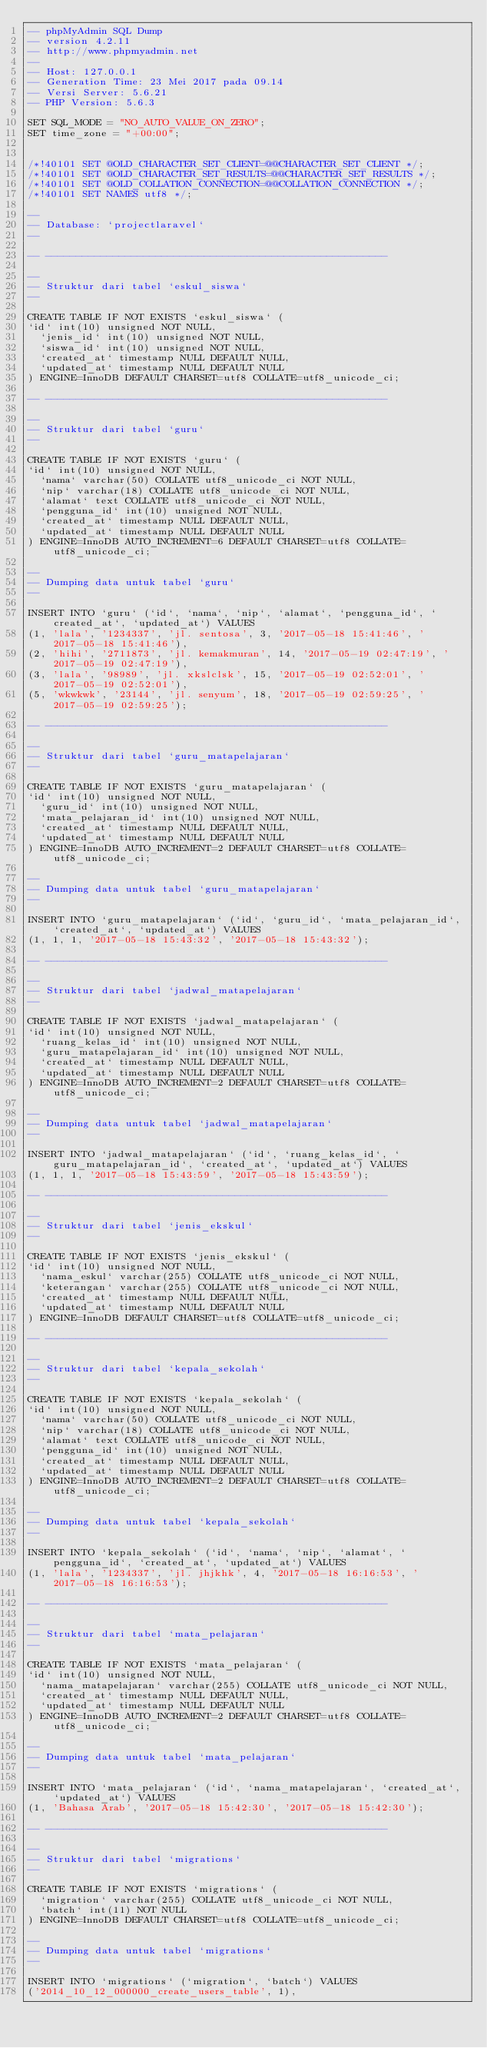Convert code to text. <code><loc_0><loc_0><loc_500><loc_500><_SQL_>-- phpMyAdmin SQL Dump
-- version 4.2.11
-- http://www.phpmyadmin.net
--
-- Host: 127.0.0.1
-- Generation Time: 23 Mei 2017 pada 09.14
-- Versi Server: 5.6.21
-- PHP Version: 5.6.3

SET SQL_MODE = "NO_AUTO_VALUE_ON_ZERO";
SET time_zone = "+00:00";


/*!40101 SET @OLD_CHARACTER_SET_CLIENT=@@CHARACTER_SET_CLIENT */;
/*!40101 SET @OLD_CHARACTER_SET_RESULTS=@@CHARACTER_SET_RESULTS */;
/*!40101 SET @OLD_COLLATION_CONNECTION=@@COLLATION_CONNECTION */;
/*!40101 SET NAMES utf8 */;

--
-- Database: `projectlaravel`
--

-- --------------------------------------------------------

--
-- Struktur dari tabel `eskul_siswa`
--

CREATE TABLE IF NOT EXISTS `eskul_siswa` (
`id` int(10) unsigned NOT NULL,
  `jenis_id` int(10) unsigned NOT NULL,
  `siswa_id` int(10) unsigned NOT NULL,
  `created_at` timestamp NULL DEFAULT NULL,
  `updated_at` timestamp NULL DEFAULT NULL
) ENGINE=InnoDB DEFAULT CHARSET=utf8 COLLATE=utf8_unicode_ci;

-- --------------------------------------------------------

--
-- Struktur dari tabel `guru`
--

CREATE TABLE IF NOT EXISTS `guru` (
`id` int(10) unsigned NOT NULL,
  `nama` varchar(50) COLLATE utf8_unicode_ci NOT NULL,
  `nip` varchar(18) COLLATE utf8_unicode_ci NOT NULL,
  `alamat` text COLLATE utf8_unicode_ci NOT NULL,
  `pengguna_id` int(10) unsigned NOT NULL,
  `created_at` timestamp NULL DEFAULT NULL,
  `updated_at` timestamp NULL DEFAULT NULL
) ENGINE=InnoDB AUTO_INCREMENT=6 DEFAULT CHARSET=utf8 COLLATE=utf8_unicode_ci;

--
-- Dumping data untuk tabel `guru`
--

INSERT INTO `guru` (`id`, `nama`, `nip`, `alamat`, `pengguna_id`, `created_at`, `updated_at`) VALUES
(1, 'lala', '1234337', 'jl. sentosa', 3, '2017-05-18 15:41:46', '2017-05-18 15:41:46'),
(2, 'hihi', '2711873', 'jl. kemakmuran', 14, '2017-05-19 02:47:19', '2017-05-19 02:47:19'),
(3, 'lala', '98989', 'jl. xkslclsk', 15, '2017-05-19 02:52:01', '2017-05-19 02:52:01'),
(5, 'wkwkwk', '23144', 'jl. senyum', 18, '2017-05-19 02:59:25', '2017-05-19 02:59:25');

-- --------------------------------------------------------

--
-- Struktur dari tabel `guru_matapelajaran`
--

CREATE TABLE IF NOT EXISTS `guru_matapelajaran` (
`id` int(10) unsigned NOT NULL,
  `guru_id` int(10) unsigned NOT NULL,
  `mata_pelajaran_id` int(10) unsigned NOT NULL,
  `created_at` timestamp NULL DEFAULT NULL,
  `updated_at` timestamp NULL DEFAULT NULL
) ENGINE=InnoDB AUTO_INCREMENT=2 DEFAULT CHARSET=utf8 COLLATE=utf8_unicode_ci;

--
-- Dumping data untuk tabel `guru_matapelajaran`
--

INSERT INTO `guru_matapelajaran` (`id`, `guru_id`, `mata_pelajaran_id`, `created_at`, `updated_at`) VALUES
(1, 1, 1, '2017-05-18 15:43:32', '2017-05-18 15:43:32');

-- --------------------------------------------------------

--
-- Struktur dari tabel `jadwal_matapelajaran`
--

CREATE TABLE IF NOT EXISTS `jadwal_matapelajaran` (
`id` int(10) unsigned NOT NULL,
  `ruang_kelas_id` int(10) unsigned NOT NULL,
  `guru_matapelajaran_id` int(10) unsigned NOT NULL,
  `created_at` timestamp NULL DEFAULT NULL,
  `updated_at` timestamp NULL DEFAULT NULL
) ENGINE=InnoDB AUTO_INCREMENT=2 DEFAULT CHARSET=utf8 COLLATE=utf8_unicode_ci;

--
-- Dumping data untuk tabel `jadwal_matapelajaran`
--

INSERT INTO `jadwal_matapelajaran` (`id`, `ruang_kelas_id`, `guru_matapelajaran_id`, `created_at`, `updated_at`) VALUES
(1, 1, 1, '2017-05-18 15:43:59', '2017-05-18 15:43:59');

-- --------------------------------------------------------

--
-- Struktur dari tabel `jenis_ekskul`
--

CREATE TABLE IF NOT EXISTS `jenis_ekskul` (
`id` int(10) unsigned NOT NULL,
  `nama_eskul` varchar(255) COLLATE utf8_unicode_ci NOT NULL,
  `keterangan` varchar(255) COLLATE utf8_unicode_ci NOT NULL,
  `created_at` timestamp NULL DEFAULT NULL,
  `updated_at` timestamp NULL DEFAULT NULL
) ENGINE=InnoDB DEFAULT CHARSET=utf8 COLLATE=utf8_unicode_ci;

-- --------------------------------------------------------

--
-- Struktur dari tabel `kepala_sekolah`
--

CREATE TABLE IF NOT EXISTS `kepala_sekolah` (
`id` int(10) unsigned NOT NULL,
  `nama` varchar(50) COLLATE utf8_unicode_ci NOT NULL,
  `nip` varchar(18) COLLATE utf8_unicode_ci NOT NULL,
  `alamat` text COLLATE utf8_unicode_ci NOT NULL,
  `pengguna_id` int(10) unsigned NOT NULL,
  `created_at` timestamp NULL DEFAULT NULL,
  `updated_at` timestamp NULL DEFAULT NULL
) ENGINE=InnoDB AUTO_INCREMENT=2 DEFAULT CHARSET=utf8 COLLATE=utf8_unicode_ci;

--
-- Dumping data untuk tabel `kepala_sekolah`
--

INSERT INTO `kepala_sekolah` (`id`, `nama`, `nip`, `alamat`, `pengguna_id`, `created_at`, `updated_at`) VALUES
(1, 'lala', '1234337', 'jl. jhjkhk', 4, '2017-05-18 16:16:53', '2017-05-18 16:16:53');

-- --------------------------------------------------------

--
-- Struktur dari tabel `mata_pelajaran`
--

CREATE TABLE IF NOT EXISTS `mata_pelajaran` (
`id` int(10) unsigned NOT NULL,
  `nama_matapelajaran` varchar(255) COLLATE utf8_unicode_ci NOT NULL,
  `created_at` timestamp NULL DEFAULT NULL,
  `updated_at` timestamp NULL DEFAULT NULL
) ENGINE=InnoDB AUTO_INCREMENT=2 DEFAULT CHARSET=utf8 COLLATE=utf8_unicode_ci;

--
-- Dumping data untuk tabel `mata_pelajaran`
--

INSERT INTO `mata_pelajaran` (`id`, `nama_matapelajaran`, `created_at`, `updated_at`) VALUES
(1, 'Bahasa Arab', '2017-05-18 15:42:30', '2017-05-18 15:42:30');

-- --------------------------------------------------------

--
-- Struktur dari tabel `migrations`
--

CREATE TABLE IF NOT EXISTS `migrations` (
  `migration` varchar(255) COLLATE utf8_unicode_ci NOT NULL,
  `batch` int(11) NOT NULL
) ENGINE=InnoDB DEFAULT CHARSET=utf8 COLLATE=utf8_unicode_ci;

--
-- Dumping data untuk tabel `migrations`
--

INSERT INTO `migrations` (`migration`, `batch`) VALUES
('2014_10_12_000000_create_users_table', 1),</code> 